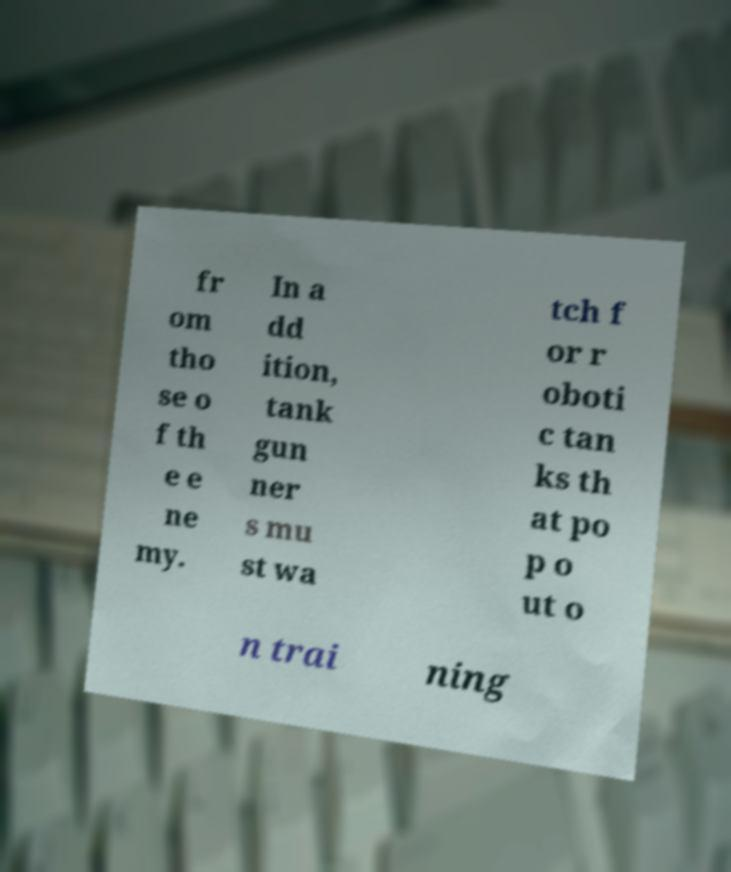What messages or text are displayed in this image? I need them in a readable, typed format. fr om tho se o f th e e ne my. In a dd ition, tank gun ner s mu st wa tch f or r oboti c tan ks th at po p o ut o n trai ning 